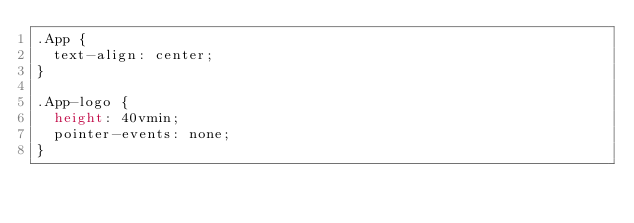Convert code to text. <code><loc_0><loc_0><loc_500><loc_500><_CSS_>.App {
  text-align: center;
}

.App-logo {
  height: 40vmin;
  pointer-events: none;
}
</code> 